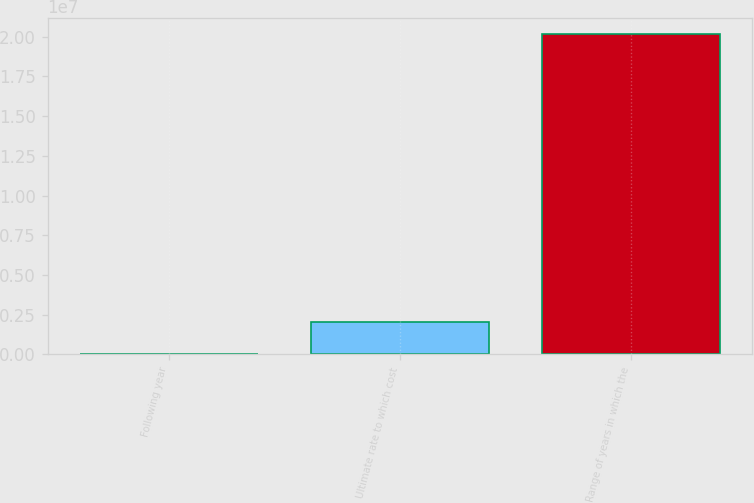<chart> <loc_0><loc_0><loc_500><loc_500><bar_chart><fcel>Following year<fcel>Ultimate rate to which cost<fcel>Range of years in which the<nl><fcel>6.87<fcel>2.01821e+06<fcel>2.0182e+07<nl></chart> 